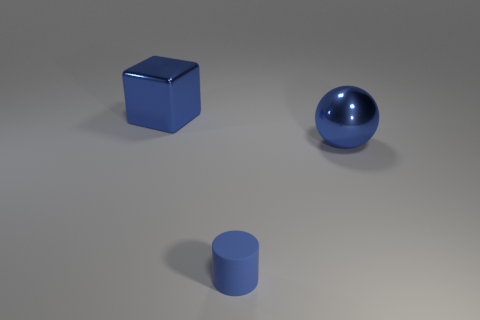What number of metal things have the same shape as the small blue matte thing?
Make the answer very short. 0. What is the shape of the small matte thing?
Your answer should be compact. Cylinder. Are there fewer small blue objects than tiny purple cylinders?
Your answer should be compact. No. Is there anything else that has the same size as the blue matte object?
Provide a short and direct response. No. Is the number of blue balls greater than the number of cyan objects?
Provide a short and direct response. Yes. How many other objects are the same color as the tiny thing?
Offer a terse response. 2. Are the small cylinder and the object that is left of the rubber object made of the same material?
Ensure brevity in your answer.  No. There is a blue shiny object that is in front of the big thing that is on the left side of the cylinder; what number of metal objects are behind it?
Your response must be concise. 1. Is the number of small blue rubber cylinders in front of the blue rubber object less than the number of metal balls in front of the large blue shiny block?
Your response must be concise. Yes. How many other things are there of the same material as the cube?
Keep it short and to the point. 1. 